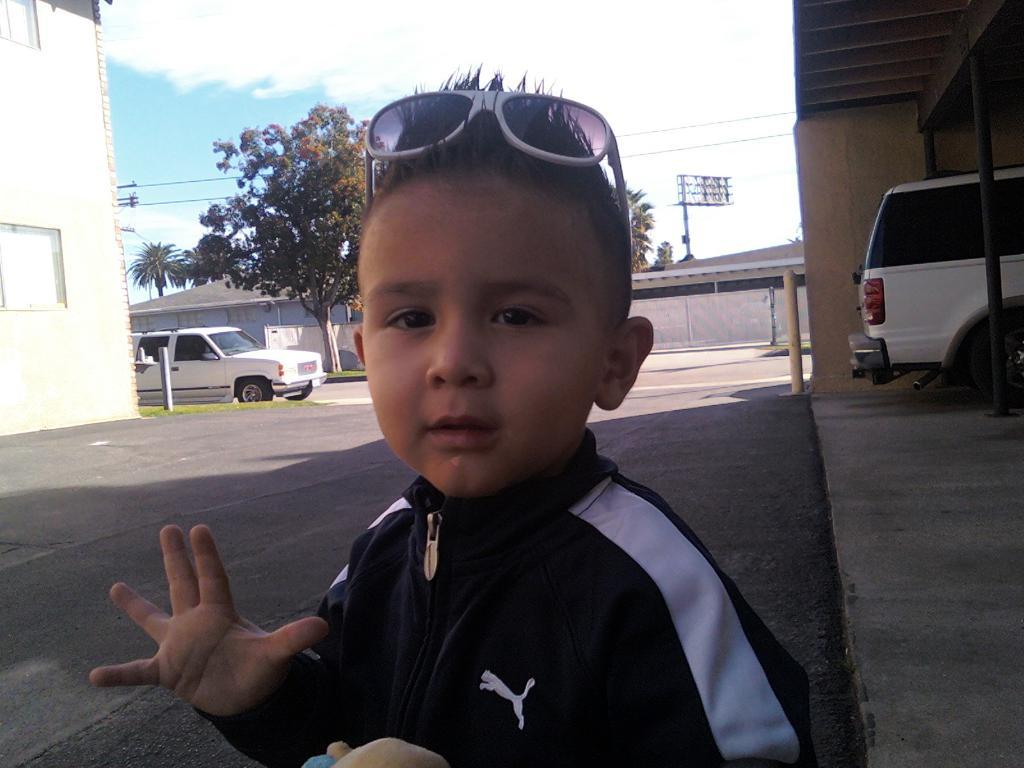What is the main subject of the image? There is a child in the image. What else can be seen in the image besides the child? Motor vehicles, trees, electric cables, sheds, a building, and the sky are visible in the image. Can you describe the sky in the image? The sky is visible in the image, and clouds are present in it. What statement does the child make about the distance between the sheds in the image? There is no statement made by the child in the image, and the distance between the sheds cannot be determined from the image. Can you tell me how many planes are flying in the sky in the image? There are no planes visible in the sky in the image. 